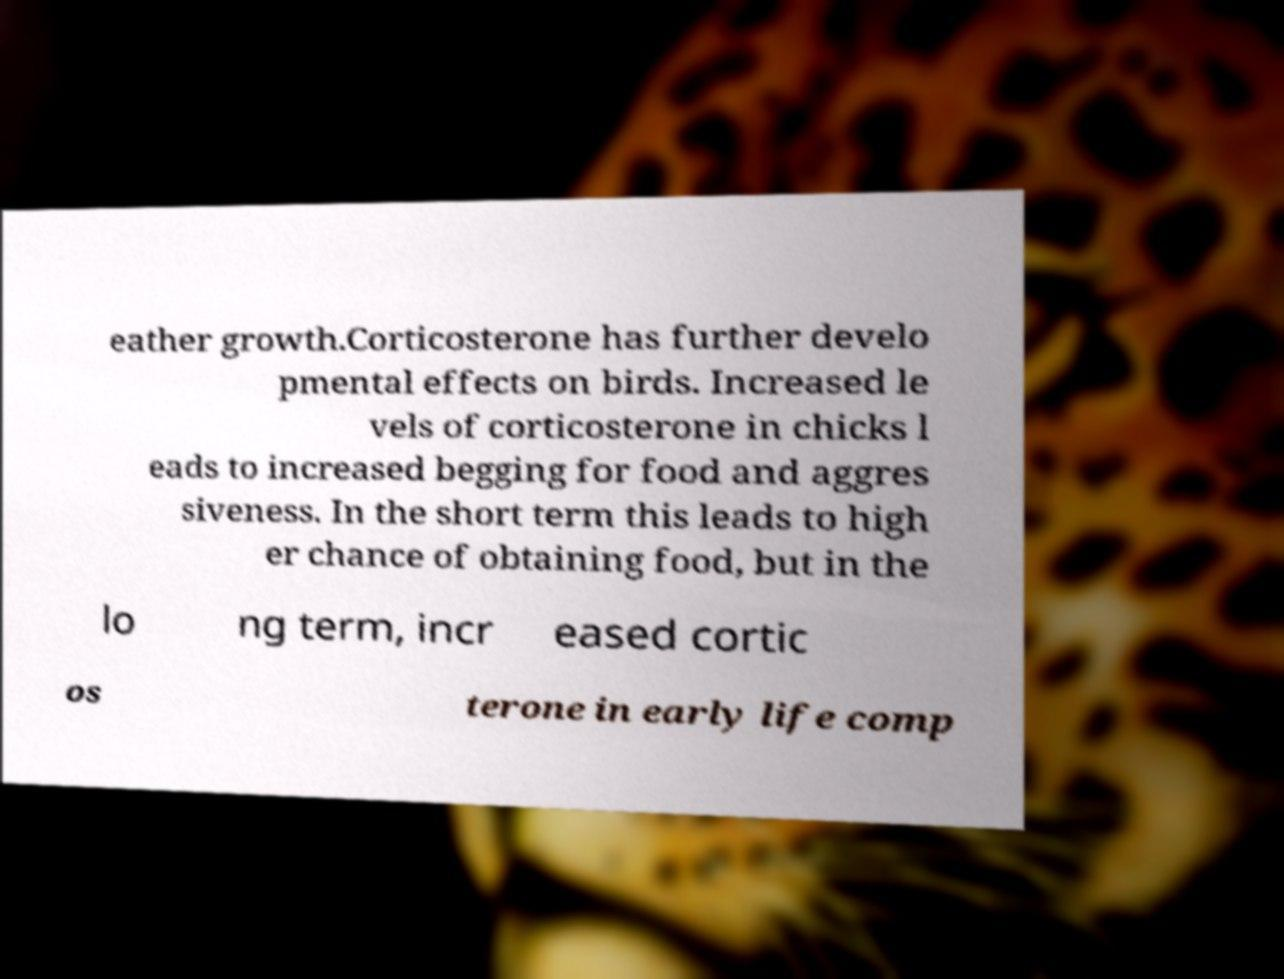I need the written content from this picture converted into text. Can you do that? eather growth.Corticosterone has further develo pmental effects on birds. Increased le vels of corticosterone in chicks l eads to increased begging for food and aggres siveness. In the short term this leads to high er chance of obtaining food, but in the lo ng term, incr eased cortic os terone in early life comp 